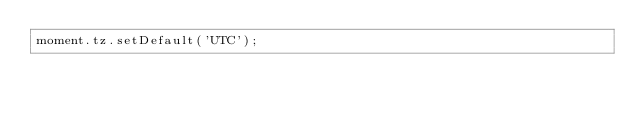Convert code to text. <code><loc_0><loc_0><loc_500><loc_500><_JavaScript_>moment.tz.setDefault('UTC');
</code> 